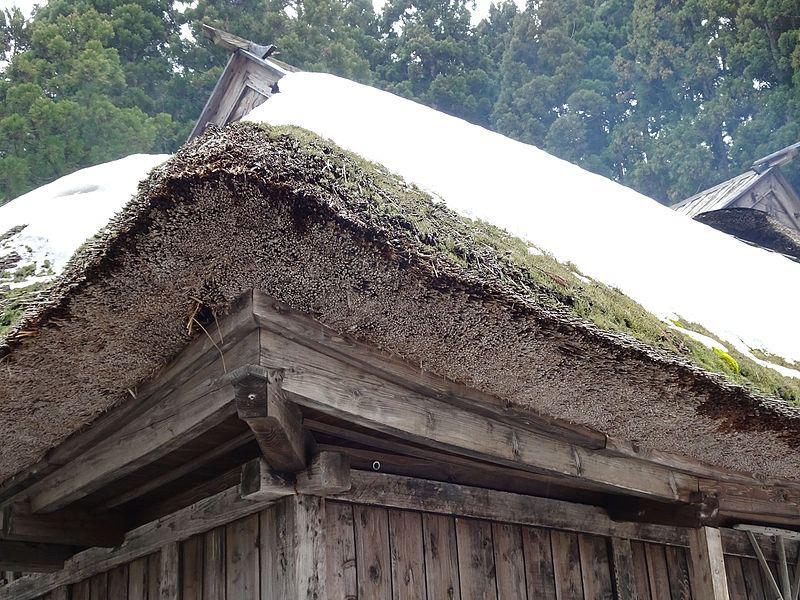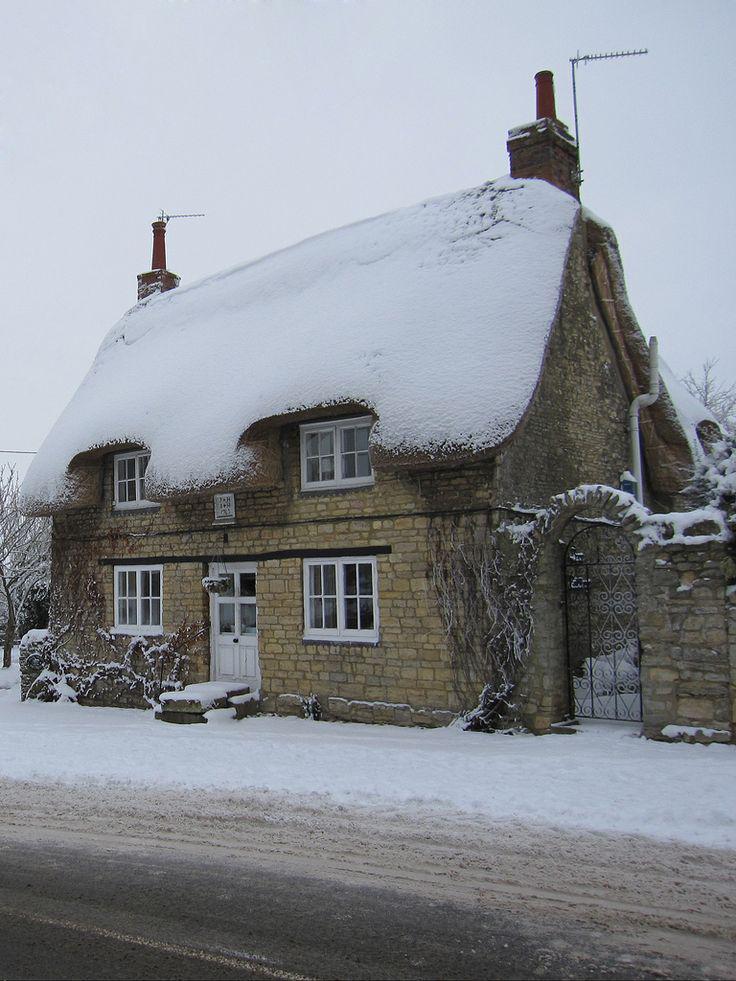The first image is the image on the left, the second image is the image on the right. Given the left and right images, does the statement "The right image shows snow covering a roof with two notches around paned windows on the upper story." hold true? Answer yes or no. Yes. The first image is the image on the left, the second image is the image on the right. Evaluate the accuracy of this statement regarding the images: "There is blue sky in at least one image.". Is it true? Answer yes or no. No. 